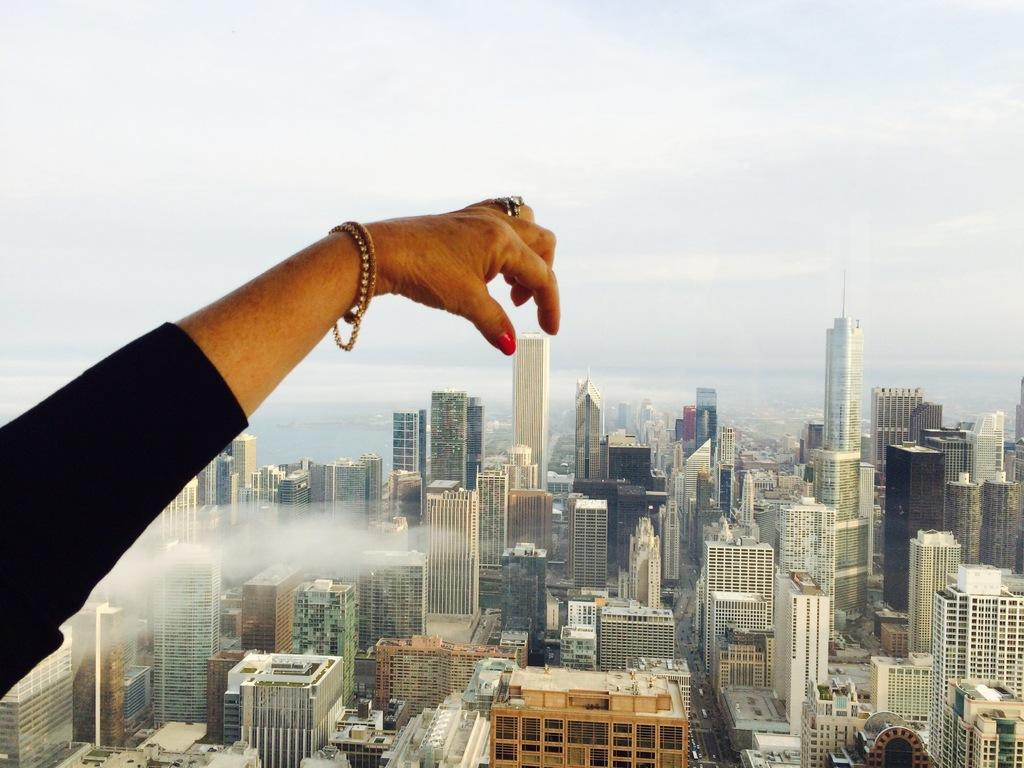What is the main subject of the image? The main subject of the image is the hand of a person. What can be seen between the person's two fingers? A tower building is seen between the person's two fingers. What else is visible in the background of the image? There are other buildings in the background of the image. How many waves can be seen crashing against the shore in the image? There are no waves visible in the image; it features a hand with a tower building between the fingers. 